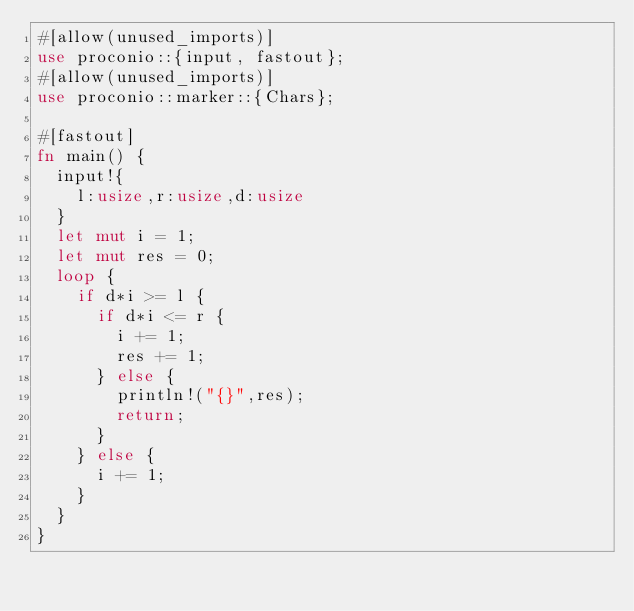<code> <loc_0><loc_0><loc_500><loc_500><_Rust_>#[allow(unused_imports)]
use proconio::{input, fastout};
#[allow(unused_imports)]
use proconio::marker::{Chars};

#[fastout]
fn main() {
  input!{
    l:usize,r:usize,d:usize
  }
  let mut i = 1;
  let mut res = 0;
  loop {
    if d*i >= l {
      if d*i <= r {
        i += 1;
        res += 1;
      } else {
        println!("{}",res);
        return;
      }
    } else {
      i += 1;
    }
  }
}
</code> 